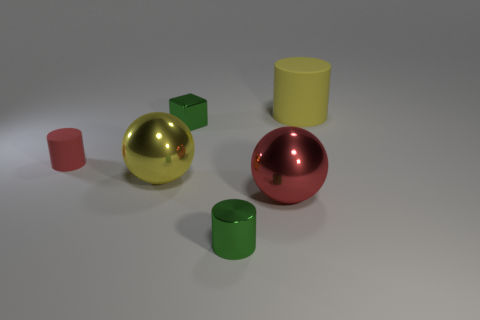What shape is the green metallic object that is left of the small metal cylinder?
Provide a short and direct response. Cube. There is a small thing that is behind the tiny green shiny cylinder and right of the tiny red rubber object; what shape is it?
Provide a short and direct response. Cube. What number of red things are either tiny cylinders or cubes?
Give a very brief answer. 1. Do the big metal object that is in front of the yellow metal sphere and the small rubber object have the same color?
Keep it short and to the point. Yes. What size is the matte cylinder behind the small shiny block that is behind the red rubber cylinder?
Ensure brevity in your answer.  Large. There is a cube that is the same size as the green cylinder; what is its material?
Keep it short and to the point. Metal. What number of other things are there of the same size as the red cylinder?
Your response must be concise. 2. How many cubes are either yellow metal objects or yellow things?
Your response must be concise. 0. What material is the large yellow thing that is to the right of the large yellow object that is in front of the matte cylinder in front of the large yellow rubber cylinder?
Your answer should be very brief. Rubber. There is a object that is the same color as the large matte cylinder; what is its material?
Provide a succinct answer. Metal. 